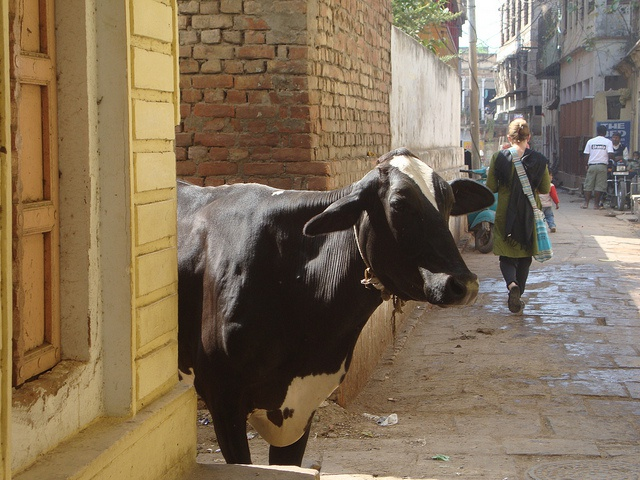Describe the objects in this image and their specific colors. I can see cow in olive, black, darkgray, and gray tones, people in olive, black, darkgreen, gray, and darkgray tones, people in olive, gray, lavender, and darkgray tones, handbag in olive, darkgray, gray, teal, and black tones, and motorcycle in olive, black, gray, and teal tones in this image. 